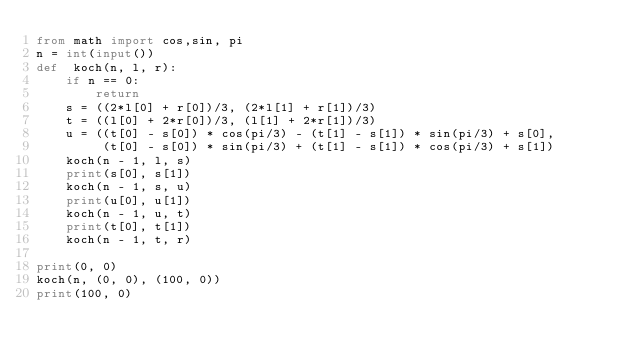Convert code to text. <code><loc_0><loc_0><loc_500><loc_500><_Python_>from math import cos,sin, pi
n = int(input())
def  koch(n, l, r):
    if n == 0:
        return
    s = ((2*l[0] + r[0])/3, (2*l[1] + r[1])/3)
    t = ((l[0] + 2*r[0])/3, (l[1] + 2*r[1])/3)
    u = ((t[0] - s[0]) * cos(pi/3) - (t[1] - s[1]) * sin(pi/3) + s[0], 
         (t[0] - s[0]) * sin(pi/3) + (t[1] - s[1]) * cos(pi/3) + s[1])
    koch(n - 1, l, s)
    print(s[0], s[1])
    koch(n - 1, s, u)
    print(u[0], u[1])
    koch(n - 1, u, t)
    print(t[0], t[1])
    koch(n - 1, t, r)

print(0, 0)
koch(n, (0, 0), (100, 0))
print(100, 0)</code> 